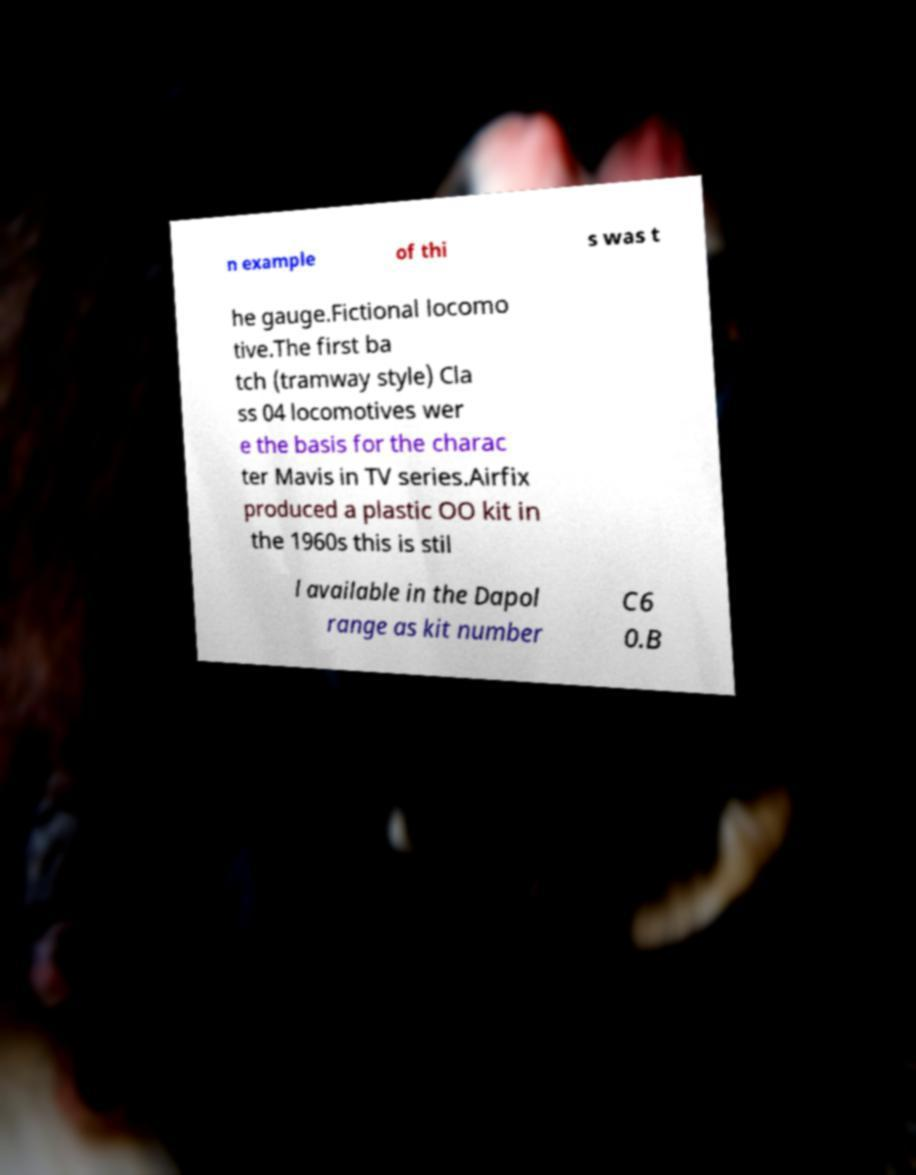Please identify and transcribe the text found in this image. n example of thi s was t he gauge.Fictional locomo tive.The first ba tch (tramway style) Cla ss 04 locomotives wer e the basis for the charac ter Mavis in TV series.Airfix produced a plastic OO kit in the 1960s this is stil l available in the Dapol range as kit number C6 0.B 